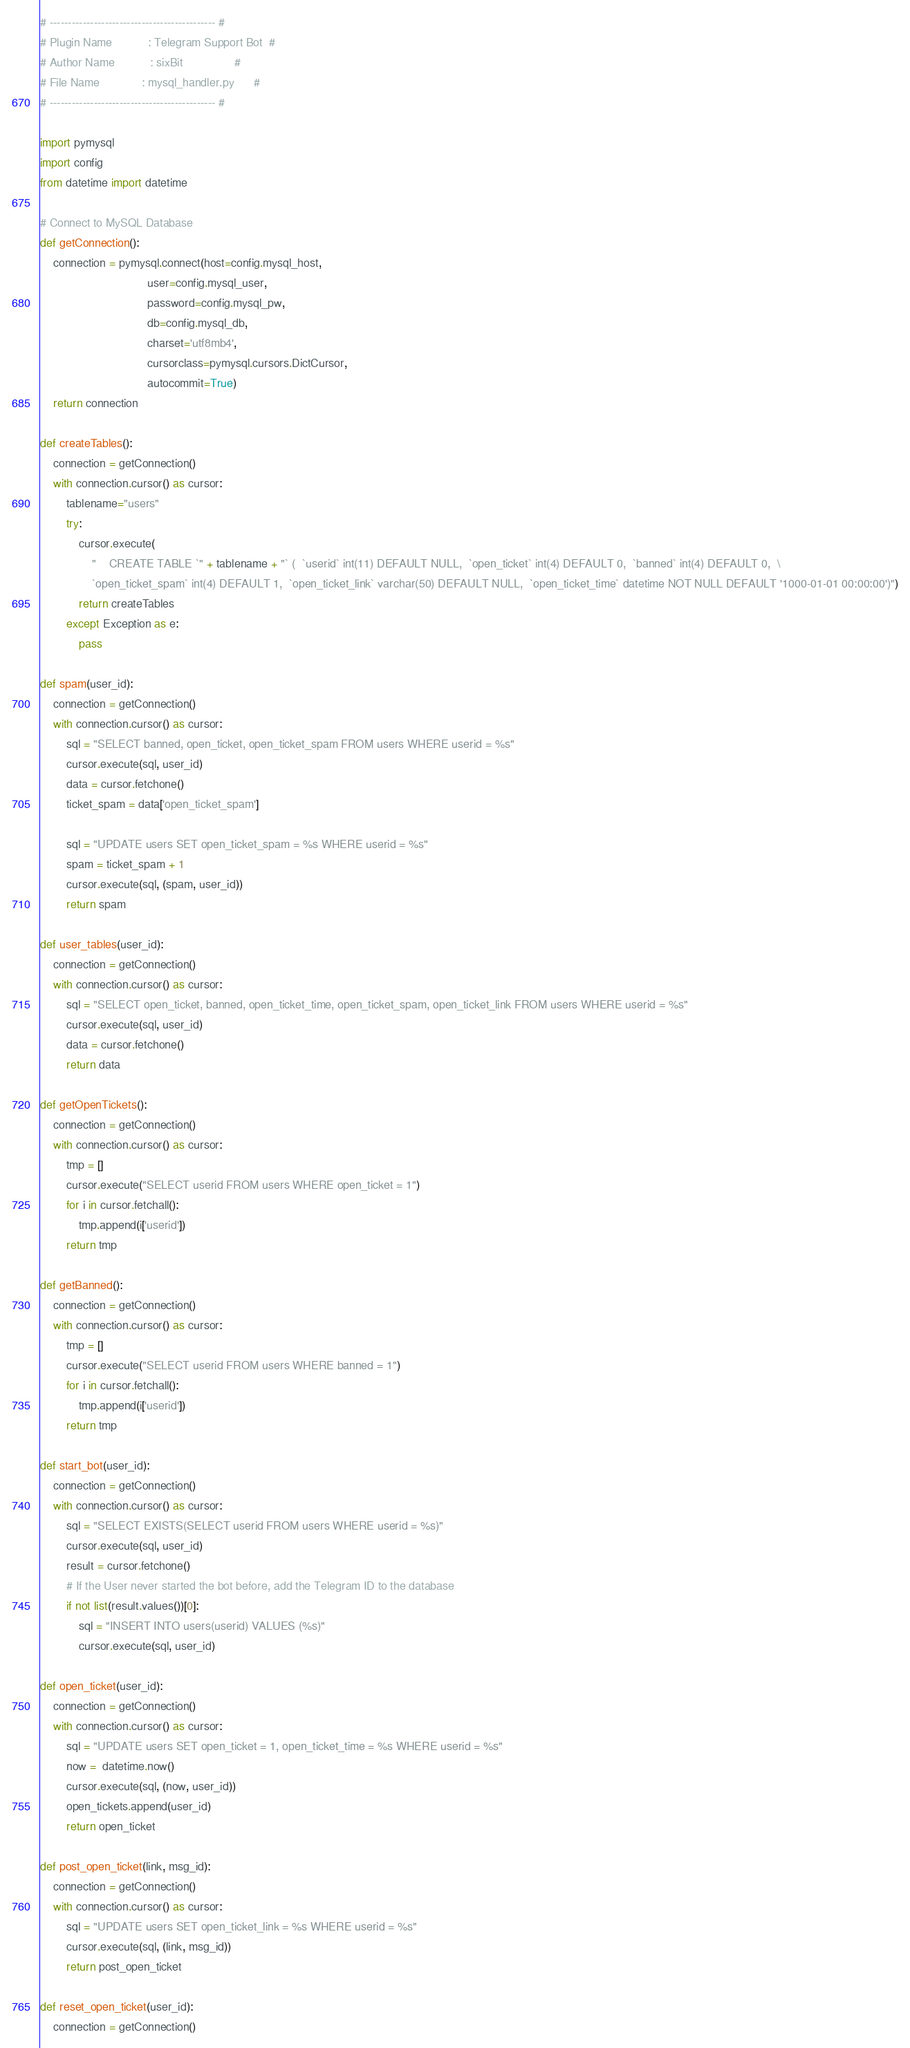Convert code to text. <code><loc_0><loc_0><loc_500><loc_500><_Python_># --------------------------------------------- #
# Plugin Name           : Telegram Support Bot  #
# Author Name           : sixBit                #
# File Name             : mysql_handler.py      #
# --------------------------------------------- #

import pymysql
import config
from datetime import datetime

# Connect to MySQL Database
def getConnection():
    connection = pymysql.connect(host=config.mysql_host,
                                 user=config.mysql_user,
                                 password=config.mysql_pw,
                                 db=config.mysql_db,
                                 charset='utf8mb4',
                                 cursorclass=pymysql.cursors.DictCursor,
                                 autocommit=True)
    return connection

def createTables():
    connection = getConnection()
    with connection.cursor() as cursor:
        tablename="users"
        try:
            cursor.execute(
                "	CREATE TABLE `" + tablename + "` (  `userid` int(11) DEFAULT NULL,  `open_ticket` int(4) DEFAULT 0,  `banned` int(4) DEFAULT 0,  \
                `open_ticket_spam` int(4) DEFAULT 1,  `open_ticket_link` varchar(50) DEFAULT NULL,  `open_ticket_time` datetime NOT NULL DEFAULT '1000-01-01 00:00:00')")
            return createTables
        except Exception as e:
            pass

def spam(user_id):
    connection = getConnection()
    with connection.cursor() as cursor:
        sql = "SELECT banned, open_ticket, open_ticket_spam FROM users WHERE userid = %s"
        cursor.execute(sql, user_id)
        data = cursor.fetchone()
        ticket_spam = data['open_ticket_spam']

        sql = "UPDATE users SET open_ticket_spam = %s WHERE userid = %s"
        spam = ticket_spam + 1
        cursor.execute(sql, (spam, user_id))
        return spam

def user_tables(user_id):
    connection = getConnection()
    with connection.cursor() as cursor:
        sql = "SELECT open_ticket, banned, open_ticket_time, open_ticket_spam, open_ticket_link FROM users WHERE userid = %s"
        cursor.execute(sql, user_id)
        data = cursor.fetchone()
        return data

def getOpenTickets():
    connection = getConnection()
    with connection.cursor() as cursor:
        tmp = []
        cursor.execute("SELECT userid FROM users WHERE open_ticket = 1")
        for i in cursor.fetchall():
            tmp.append(i['userid'])
        return tmp

def getBanned():
    connection = getConnection()
    with connection.cursor() as cursor:
        tmp = []
        cursor.execute("SELECT userid FROM users WHERE banned = 1")
        for i in cursor.fetchall():
            tmp.append(i['userid'])
        return tmp

def start_bot(user_id):
    connection = getConnection()
    with connection.cursor() as cursor:
        sql = "SELECT EXISTS(SELECT userid FROM users WHERE userid = %s)"
        cursor.execute(sql, user_id)
        result = cursor.fetchone()
        # If the User never started the bot before, add the Telegram ID to the database
        if not list(result.values())[0]:
            sql = "INSERT INTO users(userid) VALUES (%s)"
            cursor.execute(sql, user_id)

def open_ticket(user_id):
    connection = getConnection()
    with connection.cursor() as cursor:
        sql = "UPDATE users SET open_ticket = 1, open_ticket_time = %s WHERE userid = %s"
        now =  datetime.now()
        cursor.execute(sql, (now, user_id))
        open_tickets.append(user_id)
        return open_ticket

def post_open_ticket(link, msg_id):
    connection = getConnection()
    with connection.cursor() as cursor:
        sql = "UPDATE users SET open_ticket_link = %s WHERE userid = %s"
        cursor.execute(sql, (link, msg_id))
        return post_open_ticket

def reset_open_ticket(user_id):
    connection = getConnection()</code> 